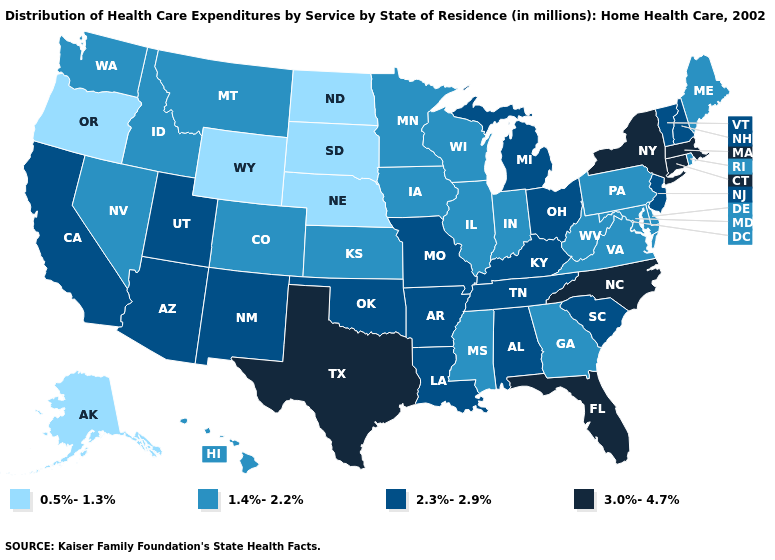What is the value of North Carolina?
Short answer required. 3.0%-4.7%. Does the first symbol in the legend represent the smallest category?
Give a very brief answer. Yes. What is the value of Utah?
Give a very brief answer. 2.3%-2.9%. What is the value of Idaho?
Concise answer only. 1.4%-2.2%. Which states have the highest value in the USA?
Be succinct. Connecticut, Florida, Massachusetts, New York, North Carolina, Texas. What is the lowest value in states that border Missouri?
Quick response, please. 0.5%-1.3%. Name the states that have a value in the range 1.4%-2.2%?
Concise answer only. Colorado, Delaware, Georgia, Hawaii, Idaho, Illinois, Indiana, Iowa, Kansas, Maine, Maryland, Minnesota, Mississippi, Montana, Nevada, Pennsylvania, Rhode Island, Virginia, Washington, West Virginia, Wisconsin. Which states hav the highest value in the West?
Write a very short answer. Arizona, California, New Mexico, Utah. Name the states that have a value in the range 0.5%-1.3%?
Keep it brief. Alaska, Nebraska, North Dakota, Oregon, South Dakota, Wyoming. Name the states that have a value in the range 3.0%-4.7%?
Short answer required. Connecticut, Florida, Massachusetts, New York, North Carolina, Texas. What is the lowest value in the South?
Quick response, please. 1.4%-2.2%. Name the states that have a value in the range 1.4%-2.2%?
Be succinct. Colorado, Delaware, Georgia, Hawaii, Idaho, Illinois, Indiana, Iowa, Kansas, Maine, Maryland, Minnesota, Mississippi, Montana, Nevada, Pennsylvania, Rhode Island, Virginia, Washington, West Virginia, Wisconsin. What is the value of New Mexico?
Answer briefly. 2.3%-2.9%. How many symbols are there in the legend?
Be succinct. 4. 